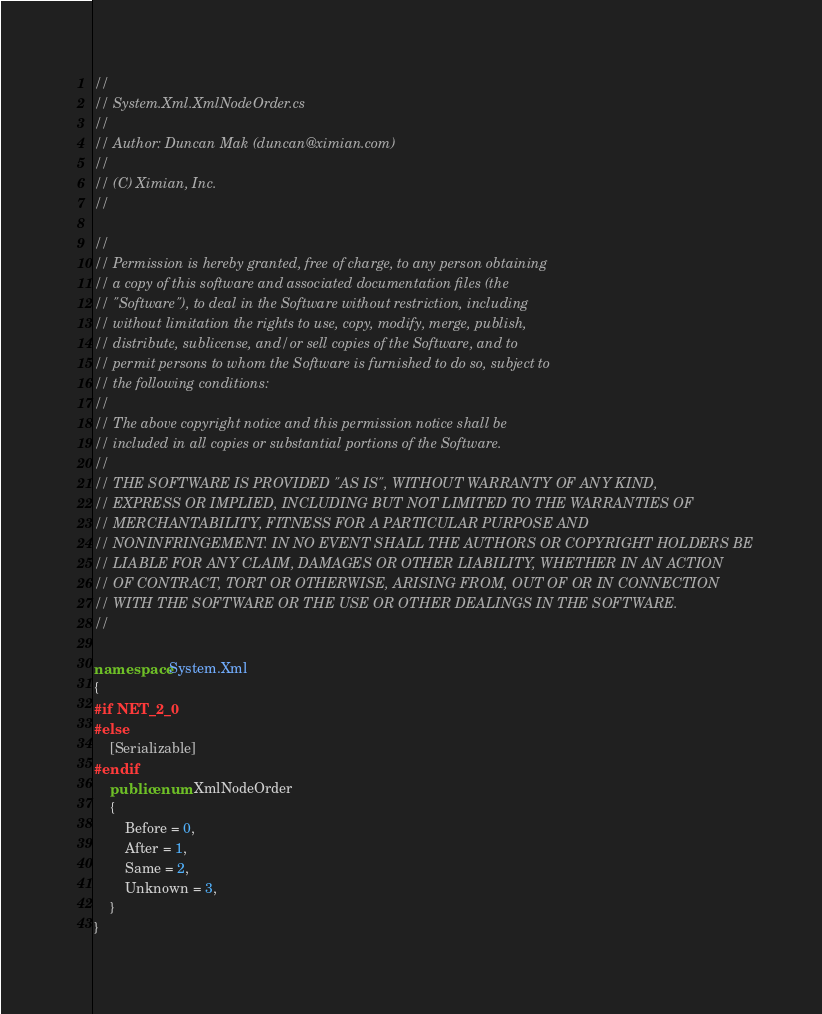<code> <loc_0><loc_0><loc_500><loc_500><_C#_>//
// System.Xml.XmlNodeOrder.cs
//
// Author: Duncan Mak (duncan@ximian.com)
//
// (C) Ximian, Inc.
//

//
// Permission is hereby granted, free of charge, to any person obtaining
// a copy of this software and associated documentation files (the
// "Software"), to deal in the Software without restriction, including
// without limitation the rights to use, copy, modify, merge, publish,
// distribute, sublicense, and/or sell copies of the Software, and to
// permit persons to whom the Software is furnished to do so, subject to
// the following conditions:
// 
// The above copyright notice and this permission notice shall be
// included in all copies or substantial portions of the Software.
// 
// THE SOFTWARE IS PROVIDED "AS IS", WITHOUT WARRANTY OF ANY KIND,
// EXPRESS OR IMPLIED, INCLUDING BUT NOT LIMITED TO THE WARRANTIES OF
// MERCHANTABILITY, FITNESS FOR A PARTICULAR PURPOSE AND
// NONINFRINGEMENT. IN NO EVENT SHALL THE AUTHORS OR COPYRIGHT HOLDERS BE
// LIABLE FOR ANY CLAIM, DAMAGES OR OTHER LIABILITY, WHETHER IN AN ACTION
// OF CONTRACT, TORT OR OTHERWISE, ARISING FROM, OUT OF OR IN CONNECTION
// WITH THE SOFTWARE OR THE USE OR OTHER DEALINGS IN THE SOFTWARE.
//

namespace System.Xml
{
#if NET_2_0
#else
	[Serializable]
#endif
	public enum XmlNodeOrder
	{
		Before = 0,
		After = 1,
		Same = 2,
		Unknown = 3,		
	}
}
</code> 